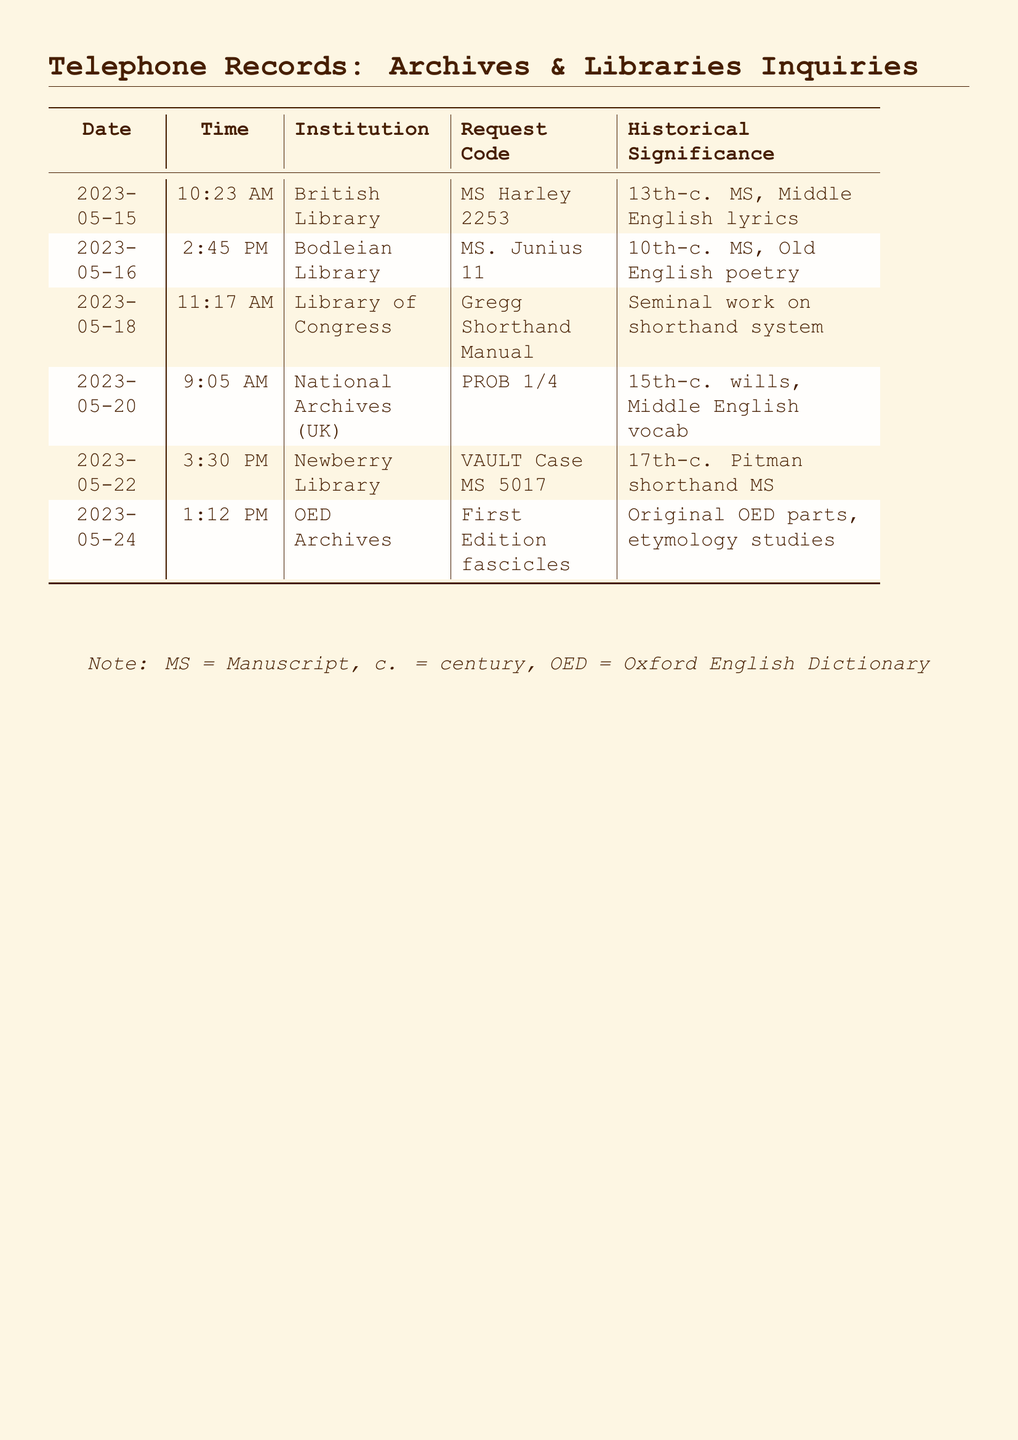What is the date of the call to the British Library? The document lists the date of the call to the British Library as May 15, 2023.
Answer: May 15, 2023 What is the request code for the 10th-century manuscript? The document indicates the request code for the 10th-century manuscript at the Bodleian Library is MS. Junius 11.
Answer: MS. Junius 11 Which institution was contacted about the Pitman shorthand manuscript? The request for the Pitman shorthand manuscript was made to the Newberry Library.
Answer: Newberry Library What is the historical significance of the Gregg Shorthand Manual? The document states the Gregg Shorthand Manual is a seminal work on the shorthand system.
Answer: Seminal work on shorthand system How many calls were made to the National Archives (UK)? The document records only one call made to the National Archives (UK) on May 20, 2023.
Answer: 1 Why are the First Edition fascicles significant? The significance of the First Edition fascicles is related to their original OED parts and etymology studies.
Answer: Original OED parts, etymology studies What century does the MS Harley 2253 manuscript belong to? According to the document, the MS Harley 2253 is a 13th-century manuscript.
Answer: 13th-century What time was the call to the Library of Congress? The call to the Library of Congress was made at 11:17 AM.
Answer: 11:17 AM Which manuscript is referred to as VAULT Case MS 5017? The VAULT Case MS 5017 is a 17th-century Pitman shorthand manuscript.
Answer: 17th-century Pitman shorthand MS 